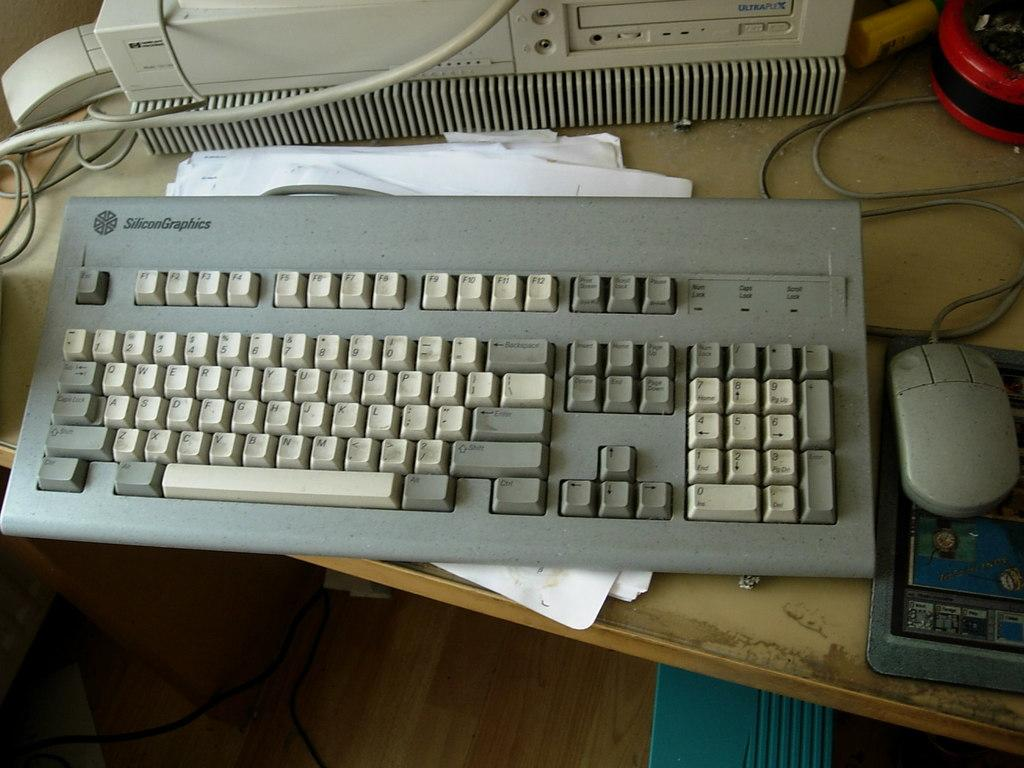What type of input device is visible in the image? There is a keyboard and a mouse in the image. What might be used for writing or documentation in the image? There are papers in the image. What type of electronic device is present in the image? There is a machine with wires in the image. What are the colors of the objects on the table? There is a red color object and a blue color object in the image. What type of waste is visible in the image? There is no waste visible in the image. What is the afterthought of the person who placed the red object on the table? There is no information about the person's intentions or afterthoughts in the image. How many cherries are on the keyboard in the image? There are no cherries present in the image. 